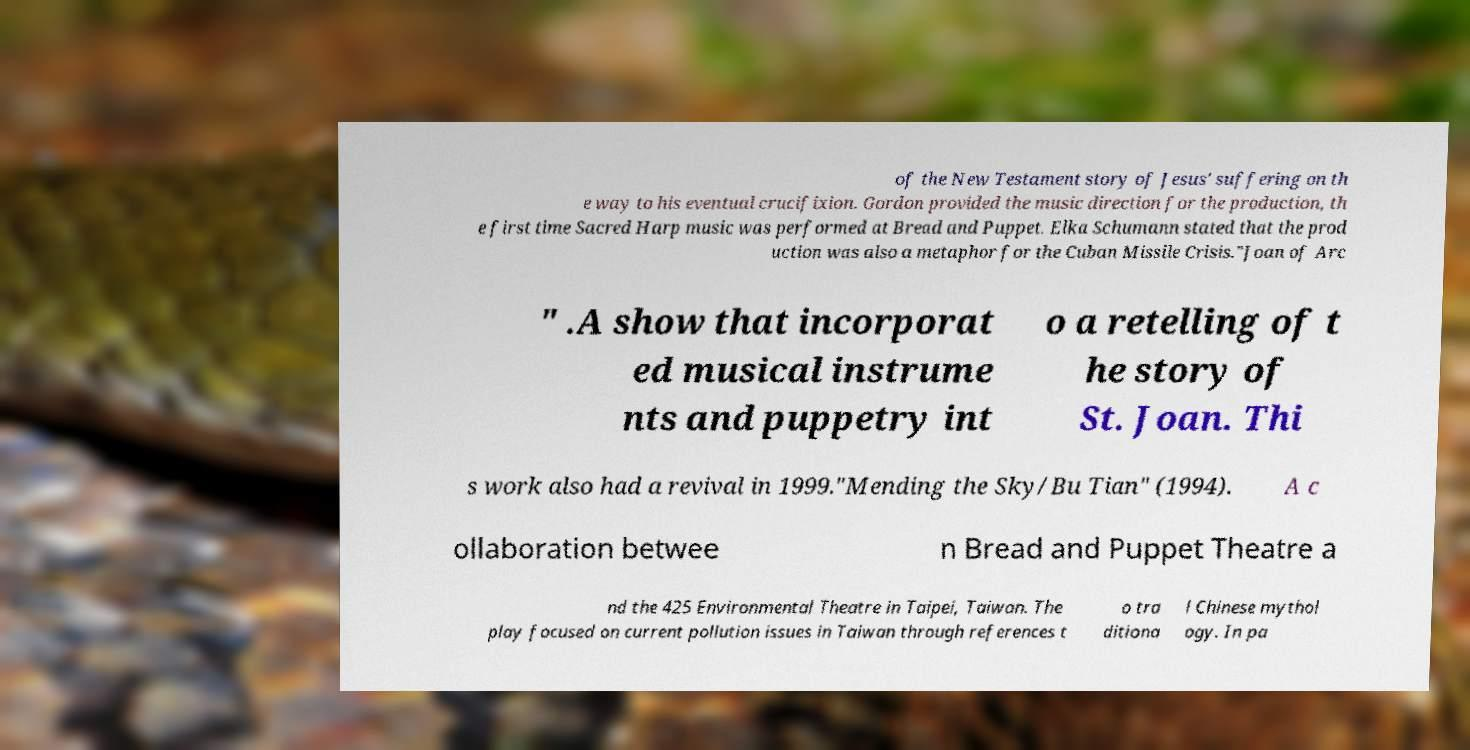For documentation purposes, I need the text within this image transcribed. Could you provide that? of the New Testament story of Jesus' suffering on th e way to his eventual crucifixion. Gordon provided the music direction for the production, th e first time Sacred Harp music was performed at Bread and Puppet. Elka Schumann stated that the prod uction was also a metaphor for the Cuban Missile Crisis."Joan of Arc " .A show that incorporat ed musical instrume nts and puppetry int o a retelling of t he story of St. Joan. Thi s work also had a revival in 1999."Mending the Sky/Bu Tian" (1994). A c ollaboration betwee n Bread and Puppet Theatre a nd the 425 Environmental Theatre in Taipei, Taiwan. The play focused on current pollution issues in Taiwan through references t o tra ditiona l Chinese mythol ogy. In pa 